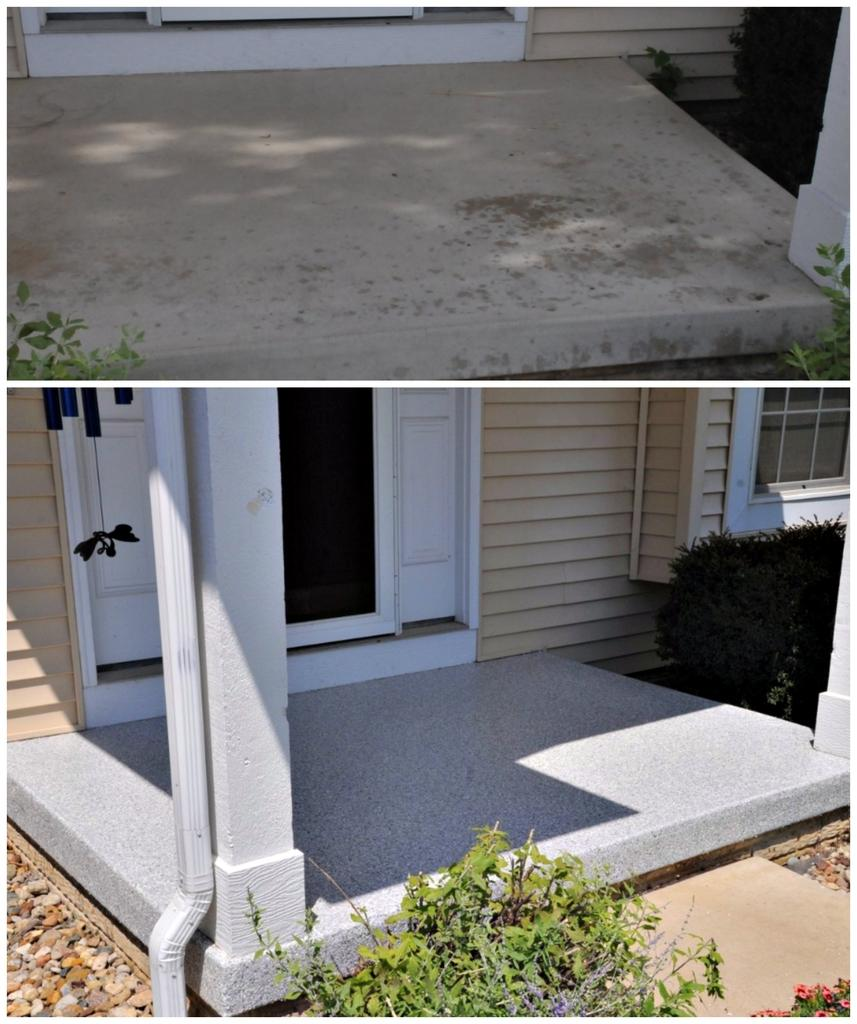What architectural feature can be seen in the image? There is a window, a wall, a pipe, pillars, and doors visible in the image. What type of vegetation is present in the image? There are plants in the image. What material is used for the floor or ground in the image? There are stones in the image, which might be used for the floor or ground. What other objects can be seen in the image? There are various objects in the image, but their specific nature is not mentioned in the facts. Can you tell me how many cows are present on the farm in the image? There is no farm or cows present in the image; it features architectural elements and plants. What type of calculator is being used by the person in the image? There is no person or calculator present in the image. 